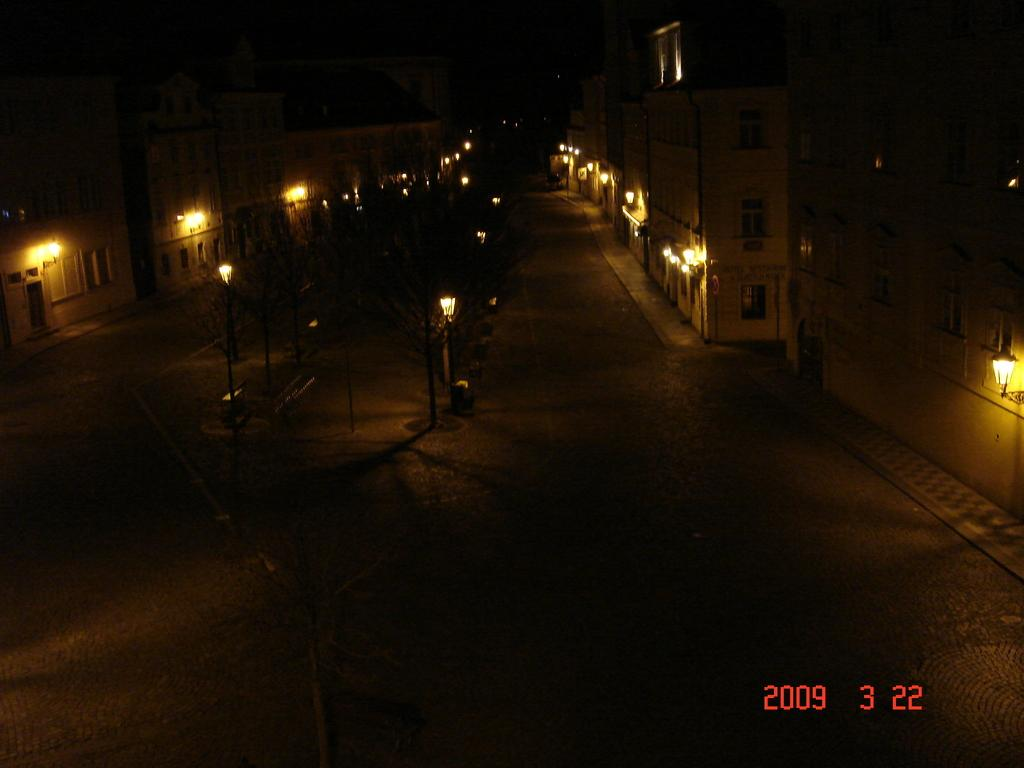What type of structures can be seen in the image? There are buildings in the image. What can be seen illuminating the scene in the image? There are lights visible in the image. What objects are present that might be used for supporting or holding something? There are poles in the image. How would you describe the overall lighting in the image? The background of the image is dark. Where can some text be found in the image? There is some text in the bottom right-hand corner of the image. What type of branch can be seen growing from the top of the building in the image? There is no branch growing from the top of the building in the image; it is not a natural structure. 